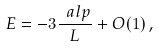<formula> <loc_0><loc_0><loc_500><loc_500>E = - 3 \frac { \ a l p } { L } + O ( 1 ) \, ,</formula> 